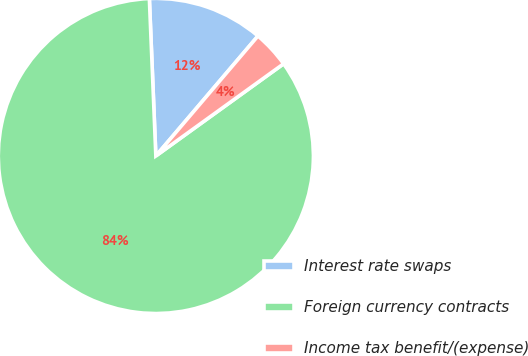<chart> <loc_0><loc_0><loc_500><loc_500><pie_chart><fcel>Interest rate swaps<fcel>Foreign currency contracts<fcel>Income tax benefit/(expense)<nl><fcel>11.88%<fcel>84.29%<fcel>3.83%<nl></chart> 